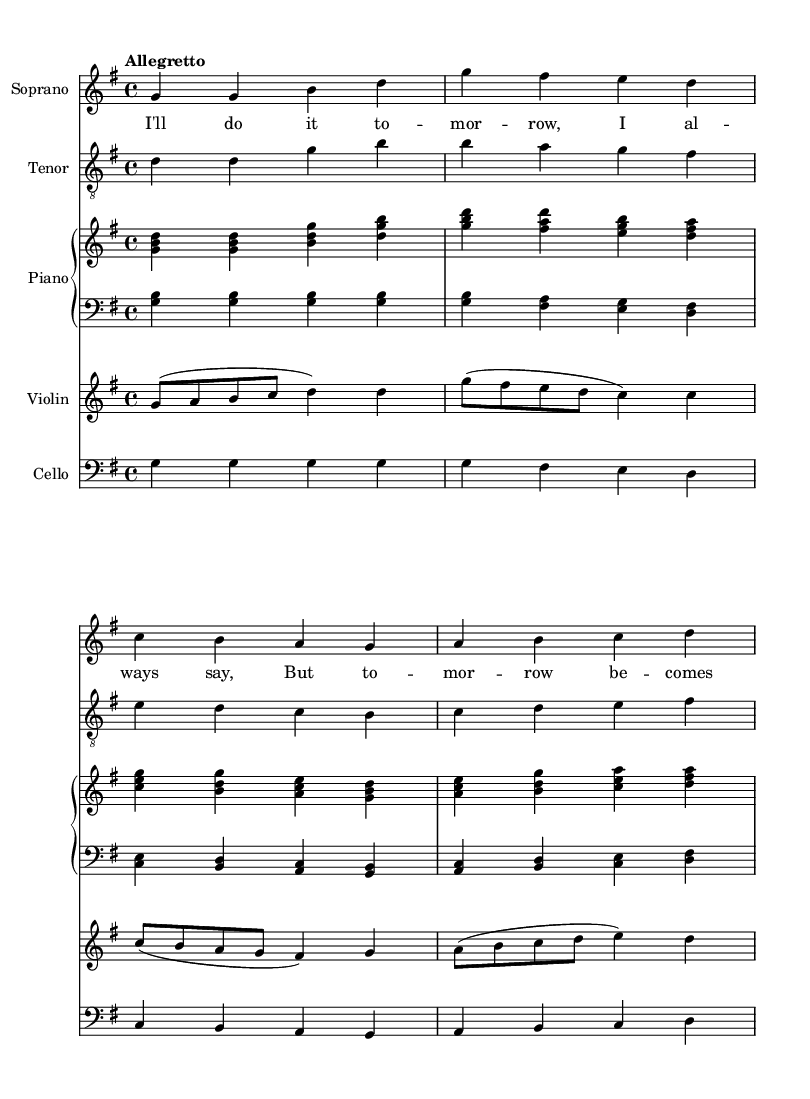What is the key signature of this music? The key signature is G major, indicated by one sharp (F#). It can be identified at the beginning of the staff right after the time signature.
Answer: G major What is the time signature of the piece? The time signature is 4/4, which indicates that there are four beats in each measure and the quarter note gets one beat. This is visible at the start of the score next to the key signature.
Answer: 4/4 What is the tempo marking for this music? The tempo marking states "Allegretto", suggesting a moderately fast pace. It can be found at the beginning of the score above the staff.
Answer: Allegretto How many voices are present in this excerpt? There are four distinct voices: soprano, tenor, piano (both right and left hand), violin, and cello, which are all clearly indicated by separate staves in the score.
Answer: Four What is the function of the 'piano' in this score? The piano serves as an accompaniment, and it has both a right hand and a left hand staff, indicating harmonic and rhythmic support for the vocal lines. The upper staff plays chords while the lower staff provides bass lines.
Answer: Accompaniment Which instrument has the melody in this section? The melody is predominantly carried by the soprano voice, as it has the highest melodic line in this excerpt. This is evident from the placement of the notes on the staff and the lyrics assigned to it.
Answer: Soprano What is the emotional tone suggested by the text "I'll do it tomorrow"? The lyrics convey a sense of procrastination, suggesting a light-hearted and humorous tone, which is typical in comic operas, as they often reflect relatable life lessons. The melody also supports this feeling through its playful rhythm.
Answer: Humorous 